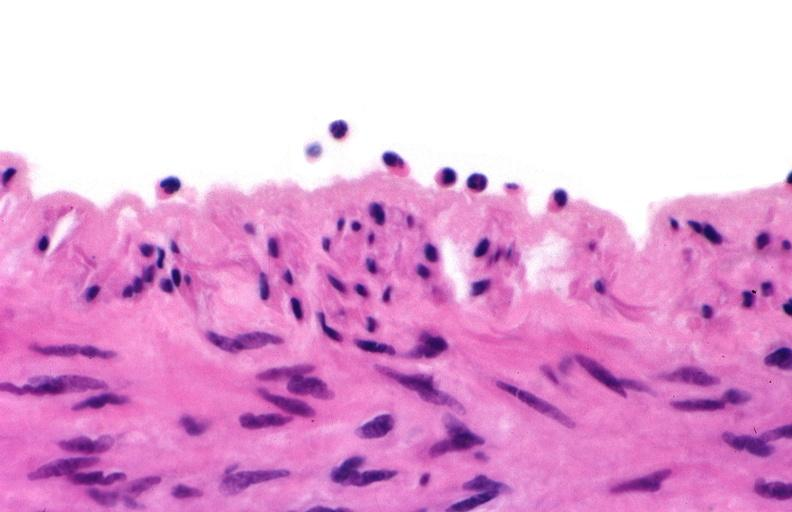does this image show acute inflammation, rolling leukocytes polymorphonuclear neutrophils?
Answer the question using a single word or phrase. Yes 